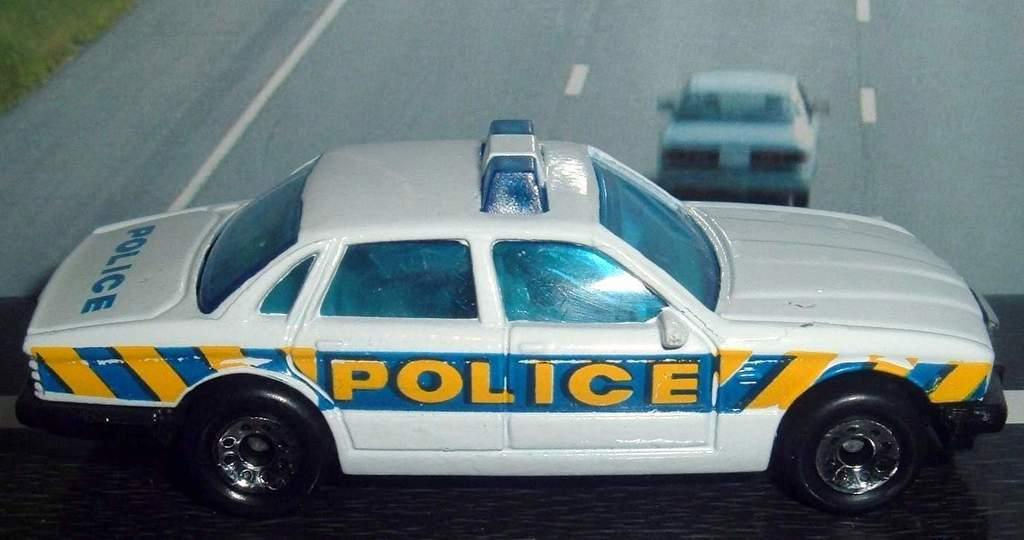What is the main object in the image? There is a toy car in the image. What is the color of the surface the toy car is placed on? The toy car is placed on a black surface. Can you describe the background of the image? There is a car visible in the background of the image, and it is on a road. What type of vegetation can be seen in the image? There is grass visible in the left side top corner of the image. What type of system is being traded in the image? There is no system or trade being depicted in the image; it features a toy car on a black surface, a car on a road in the background, and grass in the top left corner. 